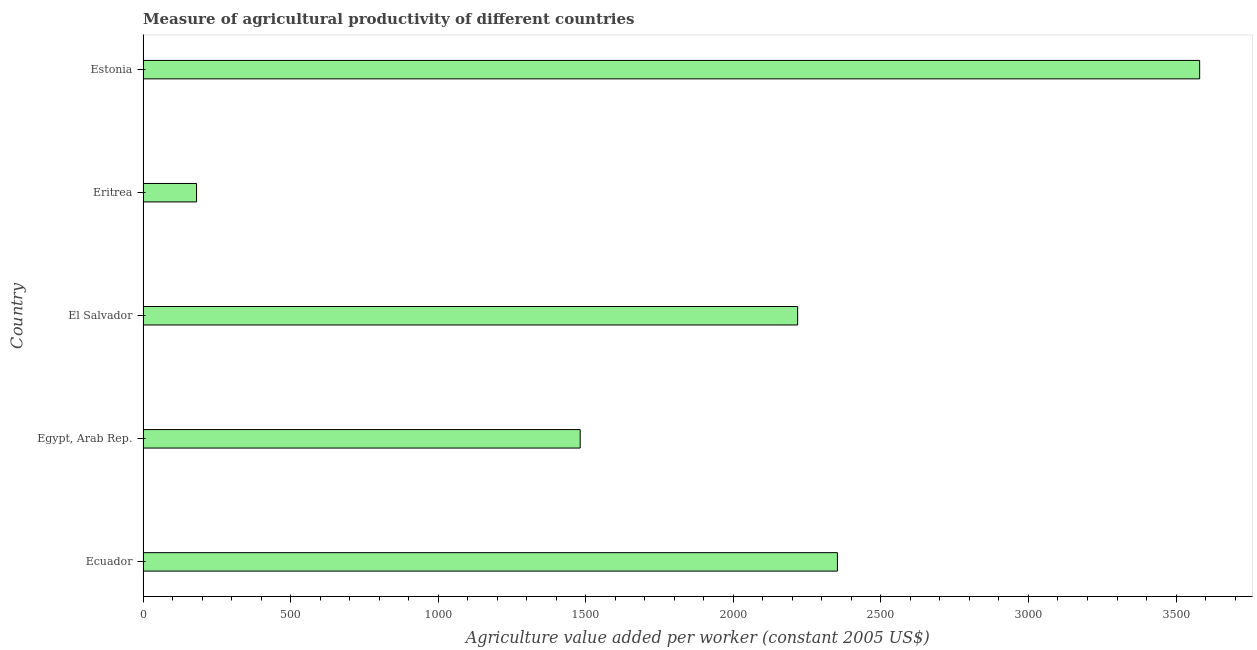Does the graph contain grids?
Your answer should be compact. No. What is the title of the graph?
Provide a short and direct response. Measure of agricultural productivity of different countries. What is the label or title of the X-axis?
Your response must be concise. Agriculture value added per worker (constant 2005 US$). What is the agriculture value added per worker in Egypt, Arab Rep.?
Provide a short and direct response. 1481.08. Across all countries, what is the maximum agriculture value added per worker?
Provide a succinct answer. 3580.04. Across all countries, what is the minimum agriculture value added per worker?
Your response must be concise. 181.21. In which country was the agriculture value added per worker maximum?
Offer a terse response. Estonia. In which country was the agriculture value added per worker minimum?
Offer a very short reply. Eritrea. What is the sum of the agriculture value added per worker?
Ensure brevity in your answer.  9812.93. What is the difference between the agriculture value added per worker in El Salvador and Estonia?
Give a very brief answer. -1362.09. What is the average agriculture value added per worker per country?
Give a very brief answer. 1962.59. What is the median agriculture value added per worker?
Give a very brief answer. 2217.96. In how many countries, is the agriculture value added per worker greater than 3100 US$?
Your response must be concise. 1. What is the ratio of the agriculture value added per worker in Ecuador to that in Egypt, Arab Rep.?
Your response must be concise. 1.59. Is the agriculture value added per worker in El Salvador less than that in Eritrea?
Keep it short and to the point. No. Is the difference between the agriculture value added per worker in Ecuador and Egypt, Arab Rep. greater than the difference between any two countries?
Make the answer very short. No. What is the difference between the highest and the second highest agriculture value added per worker?
Your response must be concise. 1227.4. Is the sum of the agriculture value added per worker in Egypt, Arab Rep. and Estonia greater than the maximum agriculture value added per worker across all countries?
Make the answer very short. Yes. What is the difference between the highest and the lowest agriculture value added per worker?
Your answer should be compact. 3398.84. How many bars are there?
Offer a very short reply. 5. What is the difference between two consecutive major ticks on the X-axis?
Provide a short and direct response. 500. What is the Agriculture value added per worker (constant 2005 US$) of Ecuador?
Your response must be concise. 2352.65. What is the Agriculture value added per worker (constant 2005 US$) of Egypt, Arab Rep.?
Offer a very short reply. 1481.08. What is the Agriculture value added per worker (constant 2005 US$) in El Salvador?
Your response must be concise. 2217.96. What is the Agriculture value added per worker (constant 2005 US$) in Eritrea?
Give a very brief answer. 181.21. What is the Agriculture value added per worker (constant 2005 US$) of Estonia?
Keep it short and to the point. 3580.04. What is the difference between the Agriculture value added per worker (constant 2005 US$) in Ecuador and Egypt, Arab Rep.?
Ensure brevity in your answer.  871.57. What is the difference between the Agriculture value added per worker (constant 2005 US$) in Ecuador and El Salvador?
Ensure brevity in your answer.  134.69. What is the difference between the Agriculture value added per worker (constant 2005 US$) in Ecuador and Eritrea?
Make the answer very short. 2171.44. What is the difference between the Agriculture value added per worker (constant 2005 US$) in Ecuador and Estonia?
Offer a very short reply. -1227.4. What is the difference between the Agriculture value added per worker (constant 2005 US$) in Egypt, Arab Rep. and El Salvador?
Ensure brevity in your answer.  -736.88. What is the difference between the Agriculture value added per worker (constant 2005 US$) in Egypt, Arab Rep. and Eritrea?
Your answer should be very brief. 1299.87. What is the difference between the Agriculture value added per worker (constant 2005 US$) in Egypt, Arab Rep. and Estonia?
Provide a short and direct response. -2098.97. What is the difference between the Agriculture value added per worker (constant 2005 US$) in El Salvador and Eritrea?
Your answer should be very brief. 2036.75. What is the difference between the Agriculture value added per worker (constant 2005 US$) in El Salvador and Estonia?
Provide a succinct answer. -1362.09. What is the difference between the Agriculture value added per worker (constant 2005 US$) in Eritrea and Estonia?
Provide a short and direct response. -3398.84. What is the ratio of the Agriculture value added per worker (constant 2005 US$) in Ecuador to that in Egypt, Arab Rep.?
Your answer should be compact. 1.59. What is the ratio of the Agriculture value added per worker (constant 2005 US$) in Ecuador to that in El Salvador?
Your answer should be very brief. 1.06. What is the ratio of the Agriculture value added per worker (constant 2005 US$) in Ecuador to that in Eritrea?
Offer a very short reply. 12.98. What is the ratio of the Agriculture value added per worker (constant 2005 US$) in Ecuador to that in Estonia?
Your answer should be very brief. 0.66. What is the ratio of the Agriculture value added per worker (constant 2005 US$) in Egypt, Arab Rep. to that in El Salvador?
Give a very brief answer. 0.67. What is the ratio of the Agriculture value added per worker (constant 2005 US$) in Egypt, Arab Rep. to that in Eritrea?
Offer a terse response. 8.17. What is the ratio of the Agriculture value added per worker (constant 2005 US$) in Egypt, Arab Rep. to that in Estonia?
Keep it short and to the point. 0.41. What is the ratio of the Agriculture value added per worker (constant 2005 US$) in El Salvador to that in Eritrea?
Your response must be concise. 12.24. What is the ratio of the Agriculture value added per worker (constant 2005 US$) in El Salvador to that in Estonia?
Keep it short and to the point. 0.62. What is the ratio of the Agriculture value added per worker (constant 2005 US$) in Eritrea to that in Estonia?
Your answer should be very brief. 0.05. 